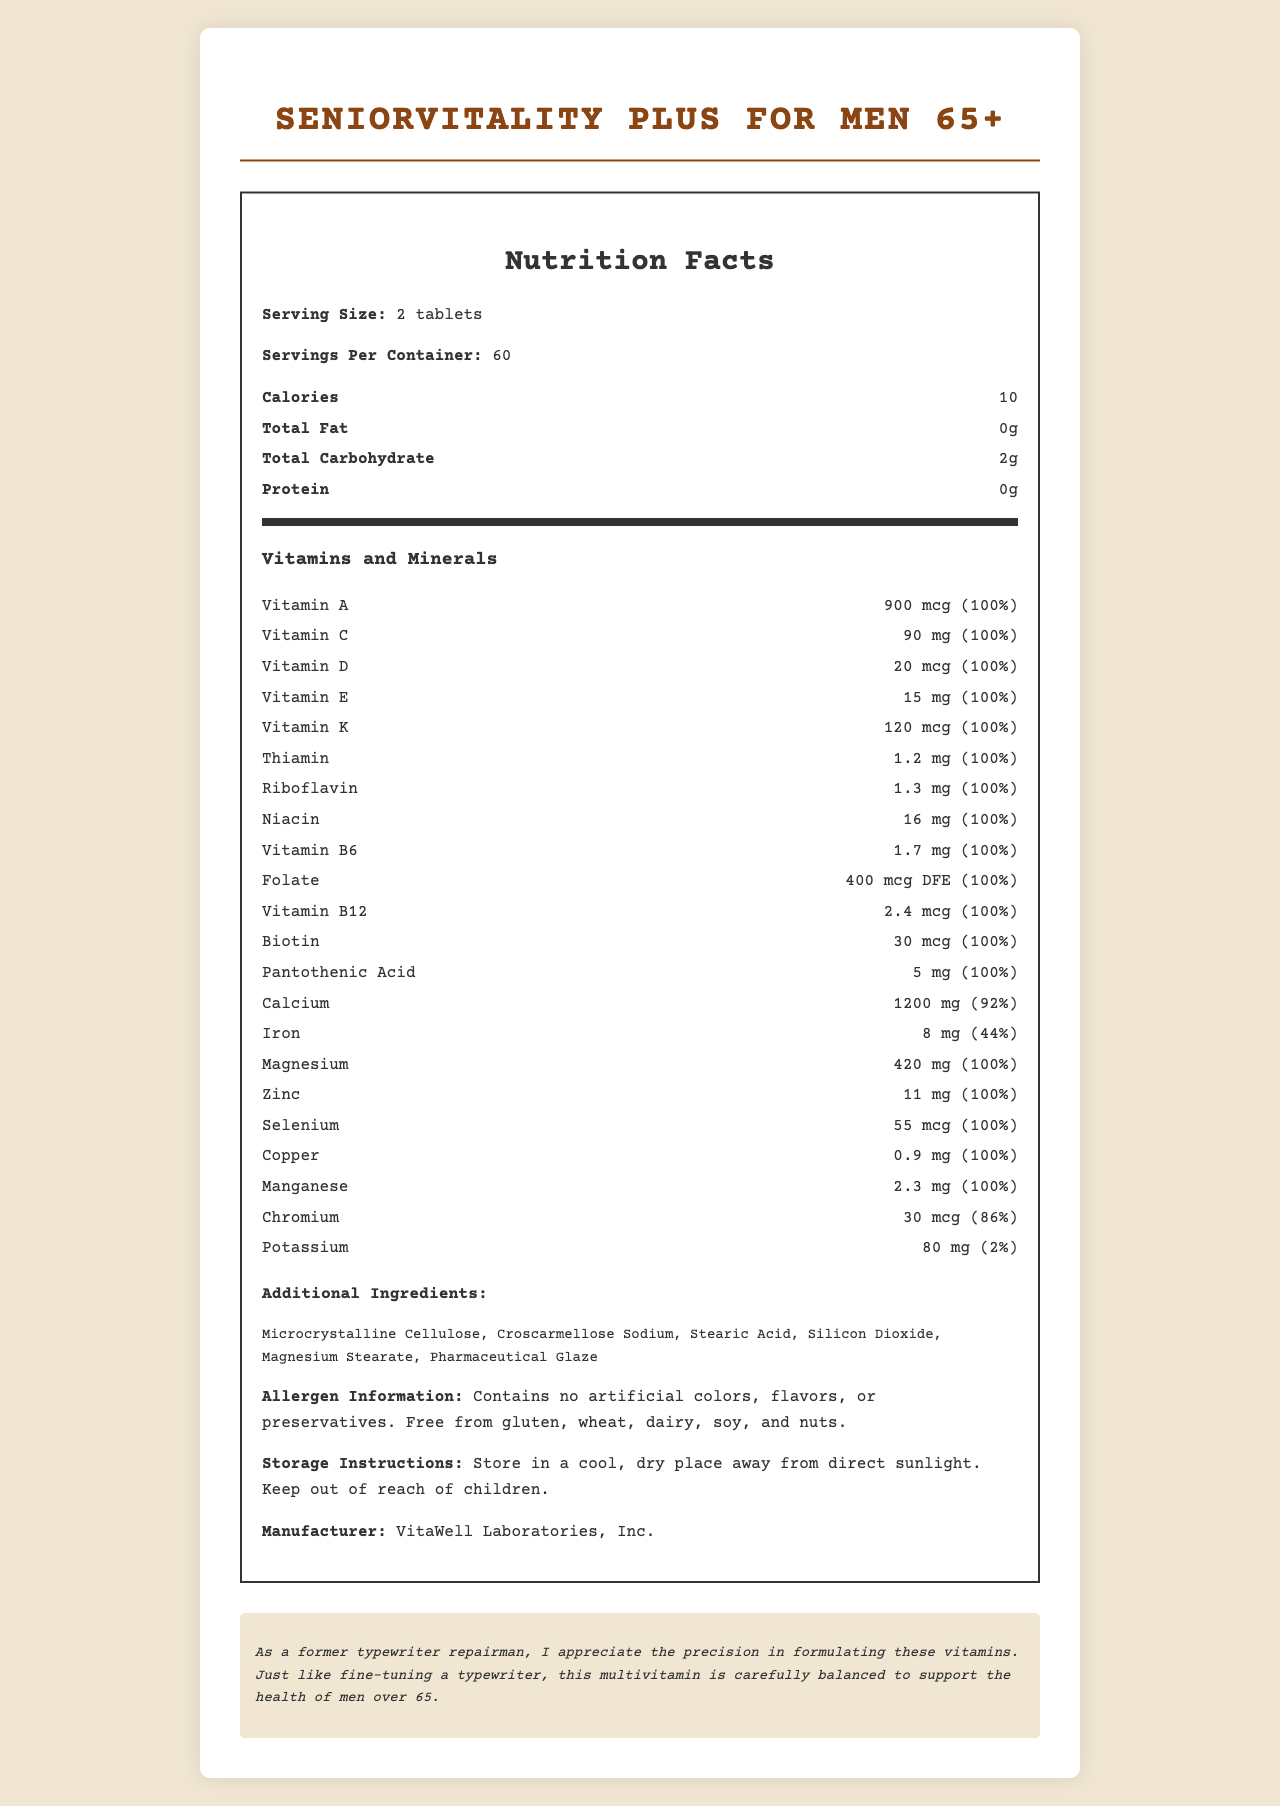what is the serving size? The serving size is mentioned at the beginning of the nutrition facts section as "Serving Size: 2 tablets".
Answer: 2 tablets how many calories are there per serving? The calories per serving are listed under the nutrition facts section, showing "Calories: 10".
Answer: 10 what is the daily value percentage of calcium? Under the vitamins and minerals section, calcium is listed with an amount of "1200 mg" and a daily value of "92%".
Answer: 92% how many servings are there per container? The information about servings per container is found near the top as "Servings Per Container: 60".
Answer: 60 which vitamin is present in the highest amount and what is it? Within the vitamins and minerals section, calcium is listed with an amount of "1200 mg", which is the highest among all the listed vitamins and minerals.
Answer: Calcium, 1200 mg what is included in the allergen information? A. Contains gluten and soy B. Free from gluten, wheat, dairy, soy, and nuts C. No allergen information provided The allergen information clearly states that the product is "Free from gluten, wheat, dairy, soy, and nuts."
Answer: B what is the daily value percentage of iron? A. 30% B. 44% C. 60% D. 80% The daily value percentage of iron is listed as "44%" in the vitamins and minerals section.
Answer: B does this multivitamin contain any artificial colors or flavors? The allergen information specifies, "Contains no artificial colors, flavors, or preservatives."
Answer: No is there protein in this multivitamin? Within the nutrition facts, protein content is listed as "0g".
Answer: No what are the storage instructions? The storage instructions are given under the specific section and state to store in a cool, dry place away from direct sunlight and to keep out of reach of children.
Answer: Store in a cool, dry place away from direct sunlight. Keep out of reach of children. what is the manufacturer of this product? The manufacturer's information is listed at the bottom as "Manufacturer: VitaWell Laboratories, Inc."
Answer: VitaWell Laboratories, Inc. which vitamin has a daily value of 100% and amount of 30 mcg? Within the vitamins and minerals section, biotin is listed with an amount of "30 mcg" and a daily value of "100%".
Answer: Biotin what are the total carbohydrates per serving? A. 0g B. 1g C. 2g D. 3g The total carbohydrates per serving are listed as "2g" under the nutrition facts section.
Answer: C does the multivitamin have a high potassium content? The potassium content is listed as "80 mg" with a daily value percentage of "2%," indicating it is not high.
Answer: No summarize the information provided in the document. The document provides comprehensive nutrition information for a multivitamin specifically formulated for men over 65, listing essential nutrients and their daily values and additional product details such as allergen information and storage instructions.
Answer: This document details the nutrition facts for "SeniorVitality Plus for Men 65+," including its serving size (2 tablets), number of servings per container (60), calorie content (10 calories per serving), and the amounts and daily values of various vitamins and minerals. It highlights that the multivitamin is free from gluten, wheat, dairy, soy, and nuts and contains no artificial colors, flavors, or preservatives. Storage instructions and manufacturer details are also provided. what is the main benefit stated for this multivitamin for men over 65? The document gives detailed nutritional information and other product details but does not explicitly state the main benefit of taking this multivitamin for men over 65.
Answer: Cannot be determined 